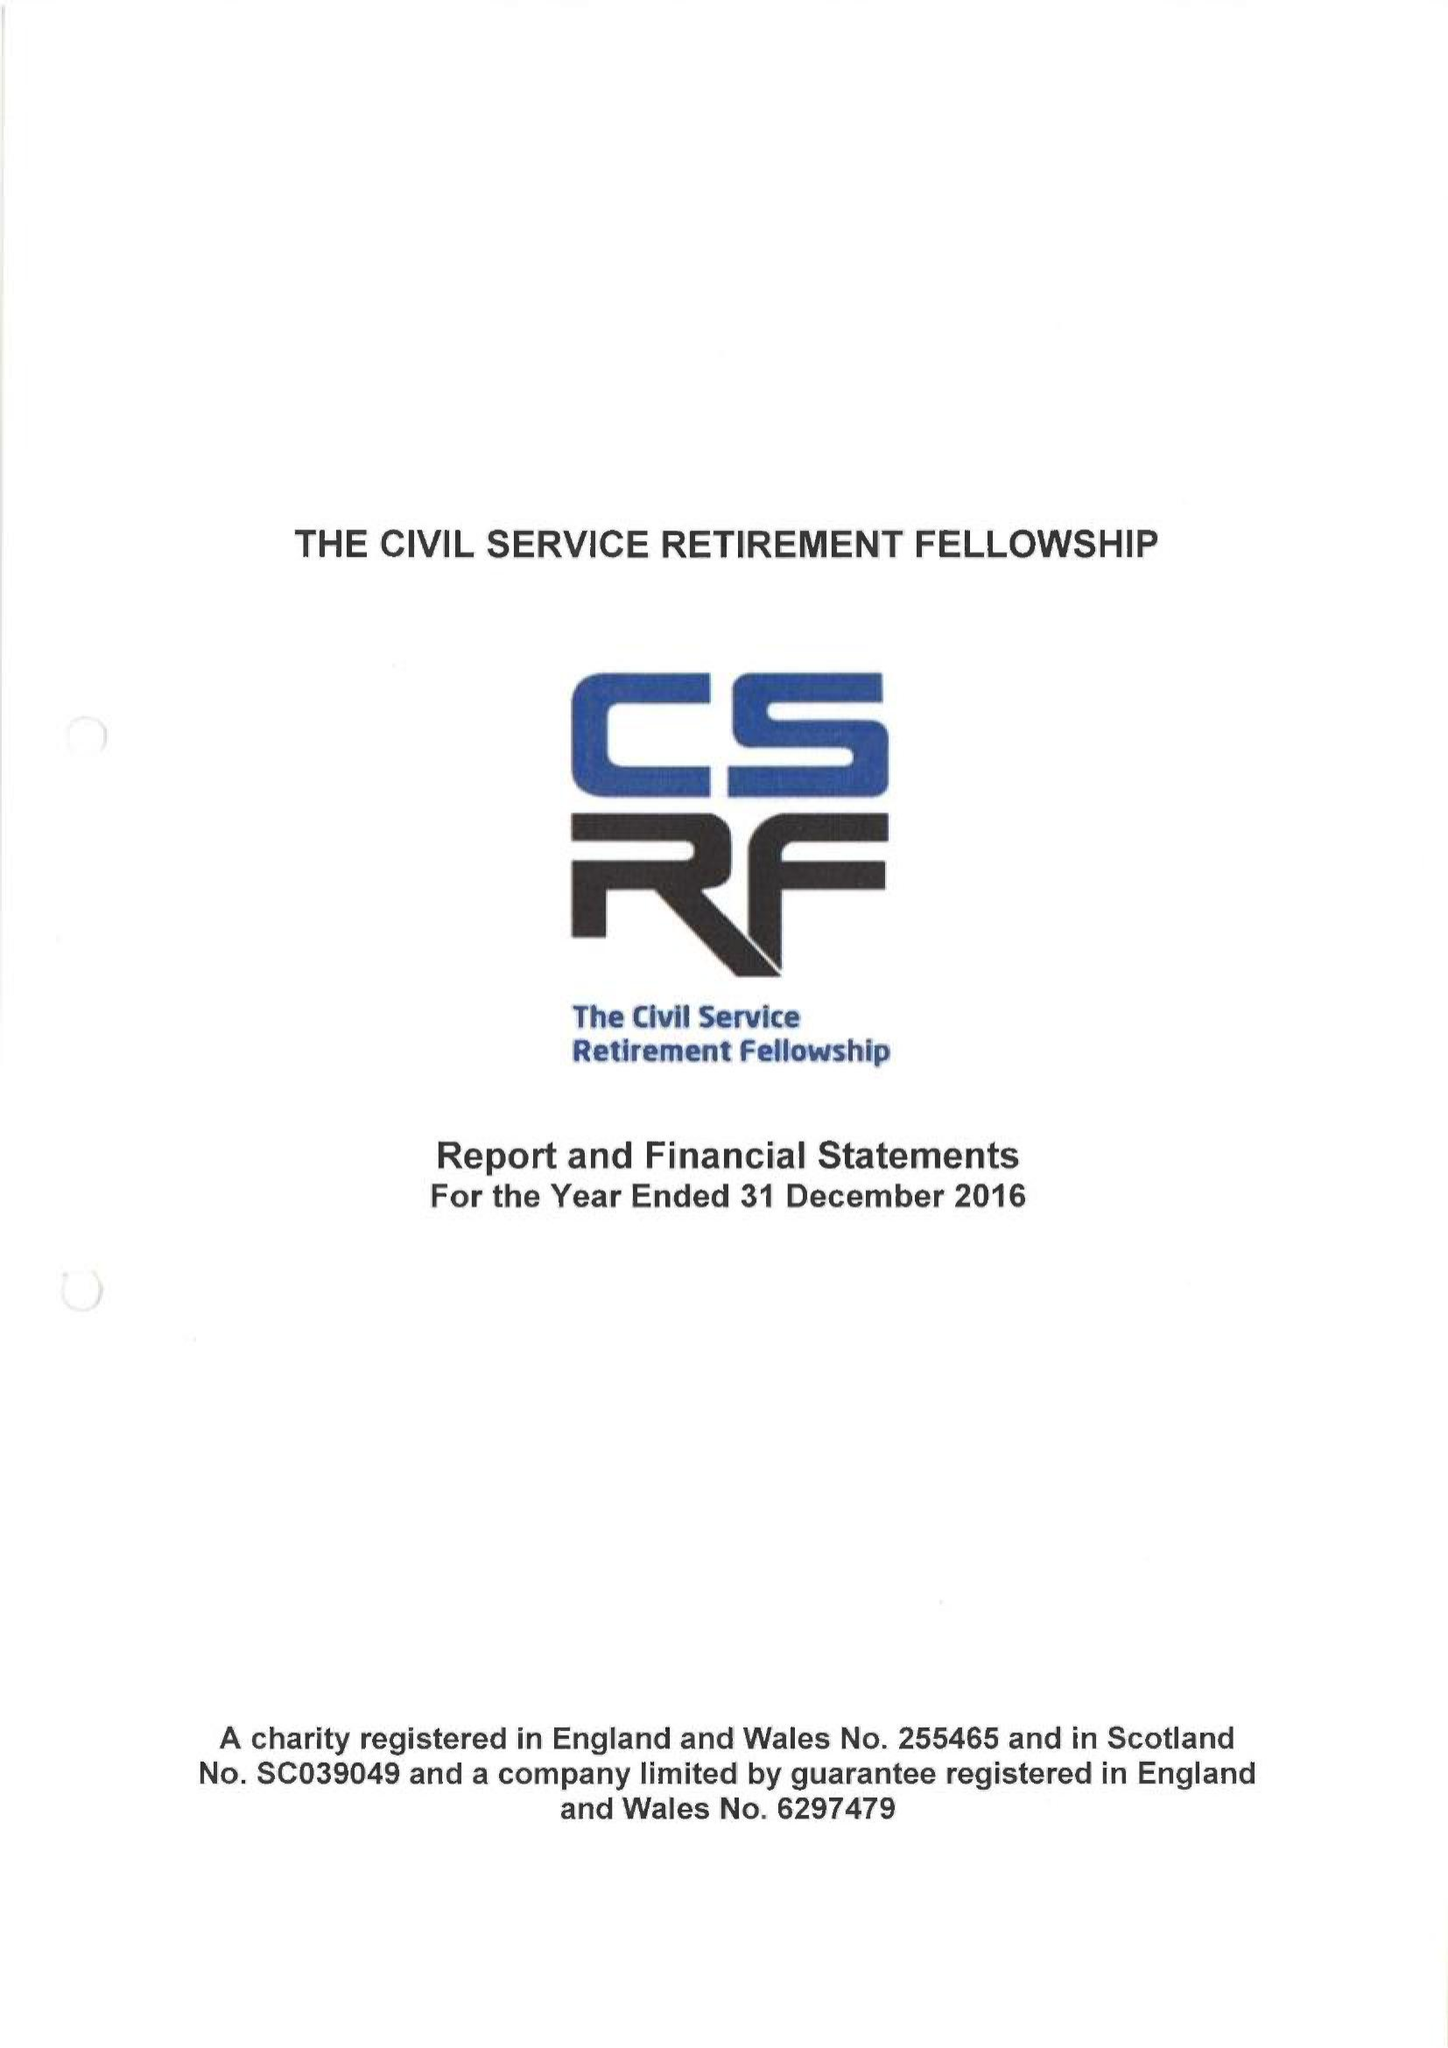What is the value for the report_date?
Answer the question using a single word or phrase. 2016-12-31 